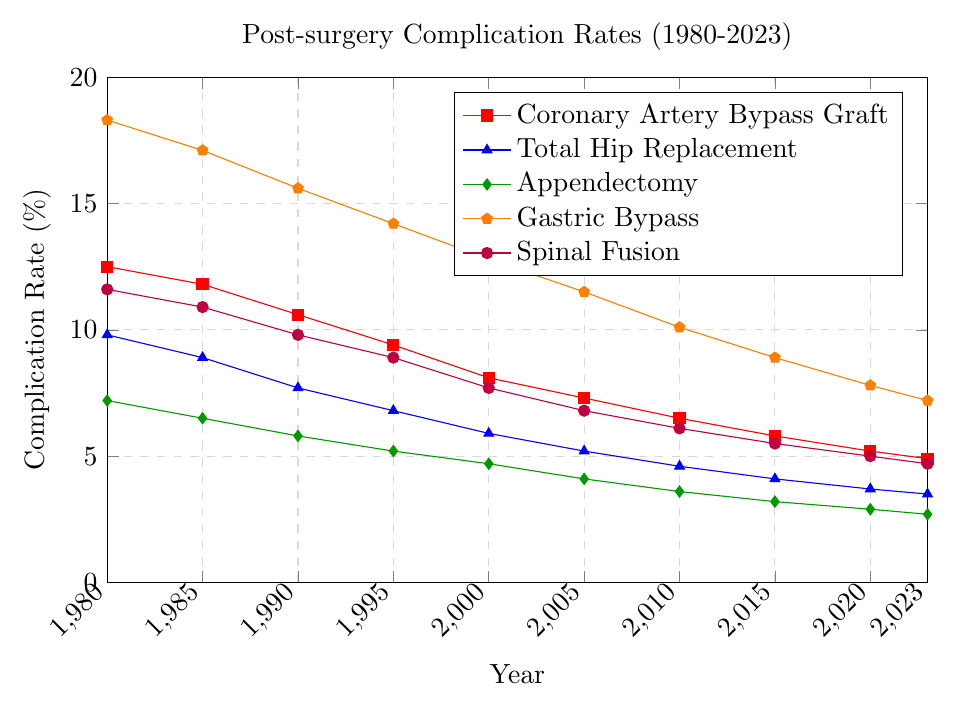What is the trend in complication rates for Coronary Artery Bypass Graft from 1980 to 2023? The complication rates for Coronary Artery Bypass Graft steadily decrease from 12.5% in 1980 to 4.9% in 2023.
Answer: Steadily decreasing Which procedure had the highest complication rate in 1990? In 1990, Gastric Bypass had the highest complication rate at 15.6%, compared to the rates of the other procedures: Coronary Artery Bypass Graft (10.6%), Total Hip Replacement (7.7%), Appendectomy (5.8%), and Spinal Fusion (9.8%).
Answer: Gastric Bypass By how much did the complication rate for Total Hip Replacement decrease from 1980 to 2023? The complication rate for Total Hip Replacement decreased from 9.8% in 1980 to 3.5% in 2023. The decrease is 9.8% - 3.5% = 6.3%.
Answer: 6.3% What is the difference in the complication rates between Appendectomy and Spinal Fusion in 2023? In 2023, the complication rate for Appendectomy is 2.7% and for Spinal Fusion it is 4.7%. The difference is 4.7% - 2.7% = 2.0%.
Answer: 2.0% Which procedure shows the most significant reduction in complication rates from 1980 to 2023? Gastric Bypass shows the most significant reduction in complication rates from 18.3% in 1980 to 7.2% in 2023. The reduction is 18.3% - 7.2% = 11.1%.
Answer: Gastric Bypass What was the complication rate for Spinal Fusion in the year 2000? From the data, the complication rate for Spinal Fusion in 2000 is shown as 7.7%.
Answer: 7.7% Between 2000 and 2010, which procedure had the smallest decrease in complication rates? From 2000 to 2010, the complication rates changed as follows: 
- Coronary Artery Bypass Graft: 8.1% to 6.5% (decrease of 1.6%)
- Total Hip Replacement: 5.9% to 4.6% (decrease of 1.3%)
- Appendectomy: 4.7% to 3.6% (decrease of 1.1%)
- Gastric Bypass: 12.8% to 10.1% (decrease of 2.7%)
- Spinal Fusion: 7.7% to 6.1% (decrease of 1.6%)
The smallest decrease is in Appendectomy.
Answer: Appendectomy How many years did it take for the complication rate of Gastric Bypass to fall below 10%? The complication rate for Gastric Bypass fell below 10% in 2010, starting from 1980. This took 2010 - 1980 = 30 years.
Answer: 30 years If the complication rates for Appendectomy continued to decrease at the same rate as they did from 2015 to 2023, what would be the complication rate in 2025? The rate of decrease from 2015 (3.2%) to 2023 (2.7%) is (3.2% - 2.7%) / 8 years = 0.0625% per year. Therefore, for the next 2 years: 2.7% - (2 * 0.0625%) = 2.575%.
Answer: 2.575% What is the average complication rate for all procedures in 2023? The complication rates in 2023 are:
- Coronary Artery Bypass Graft: 4.9%
- Total Hip Replacement: 3.5%
- Appendectomy: 2.7%
- Gastric Bypass: 7.2%
- Spinal Fusion: 4.7%
The average is (4.9 + 3.5 + 2.7 + 7.2 + 4.7) / 5 = 23 / 5 = 4.6%.
Answer: 4.6% 